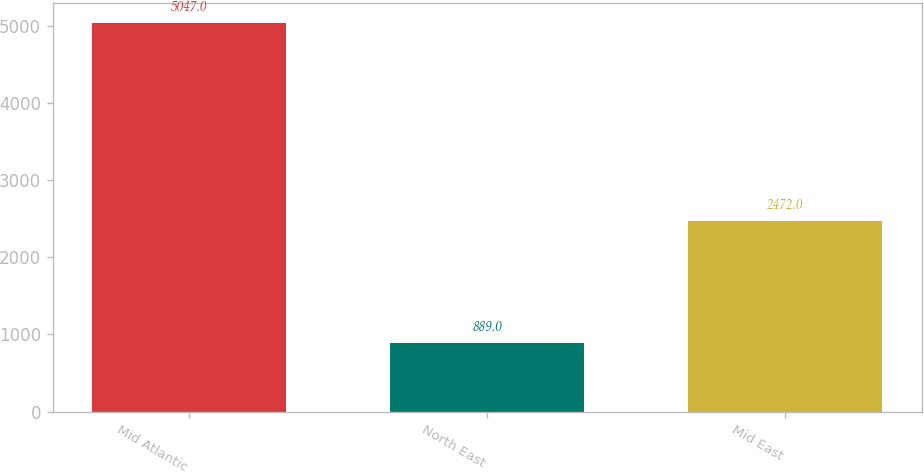Convert chart. <chart><loc_0><loc_0><loc_500><loc_500><bar_chart><fcel>Mid Atlantic<fcel>North East<fcel>Mid East<nl><fcel>5047<fcel>889<fcel>2472<nl></chart> 